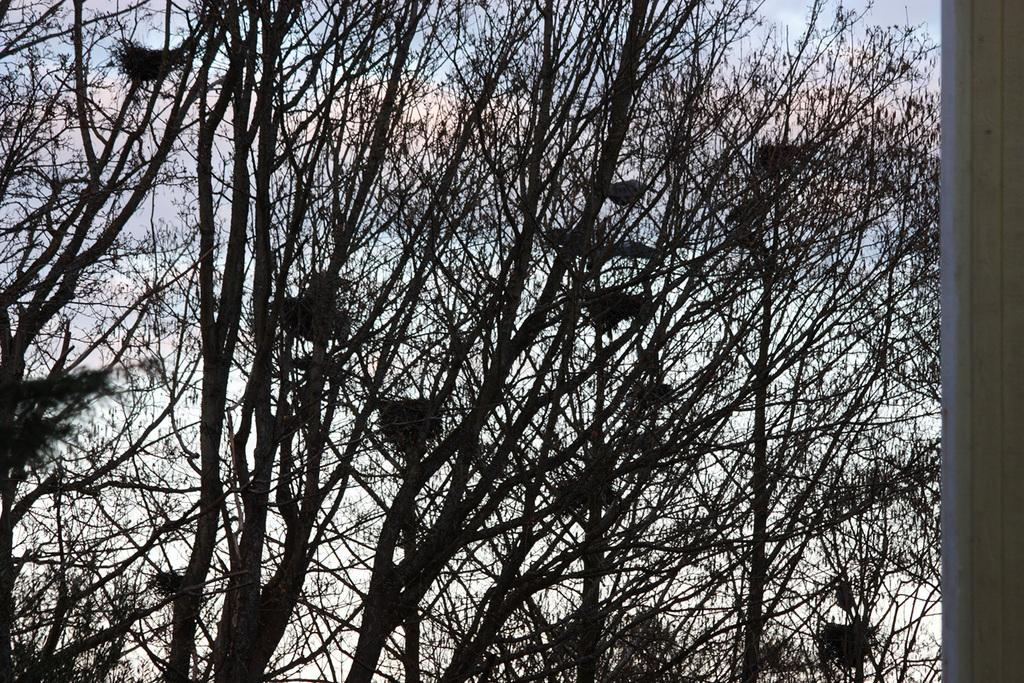What can be found in the trees in the image? There are nests in the trees in the image. What is visible in the image besides the nests? The trees themselves are visible in the image. What can be seen in the sky in the background of the image? There are clouds in the sky in the background of the image. What type of skin care product is visible in the image? There is no skin care product visible in the image. Is there any soap present in the image? There is no soap present in the image. 